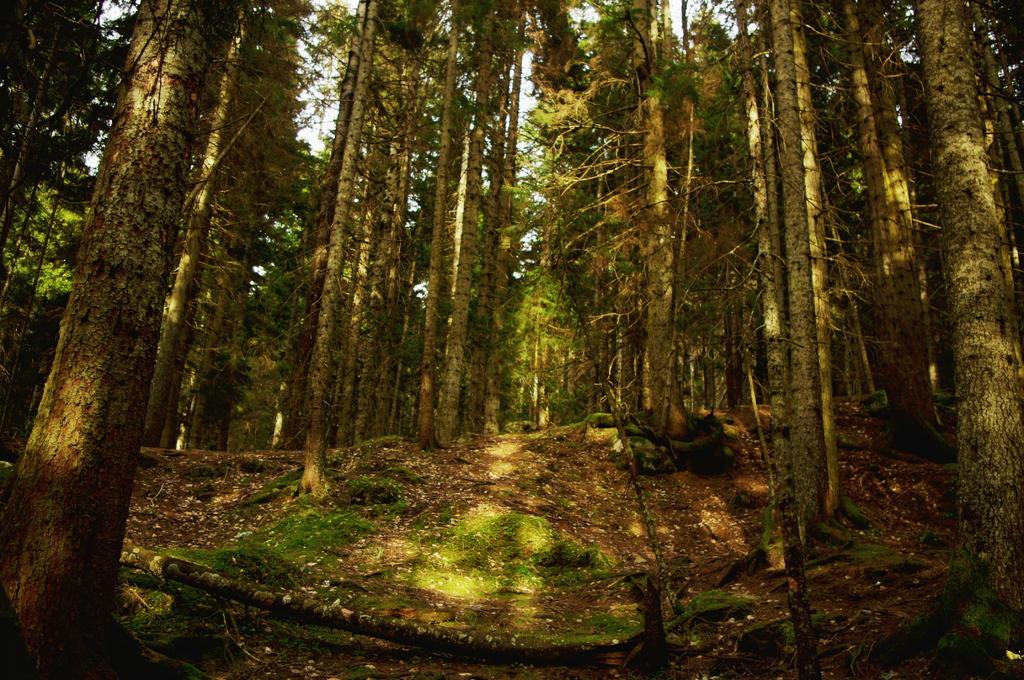Can you describe this image briefly? In this image we can see a group of trees and the sky. 